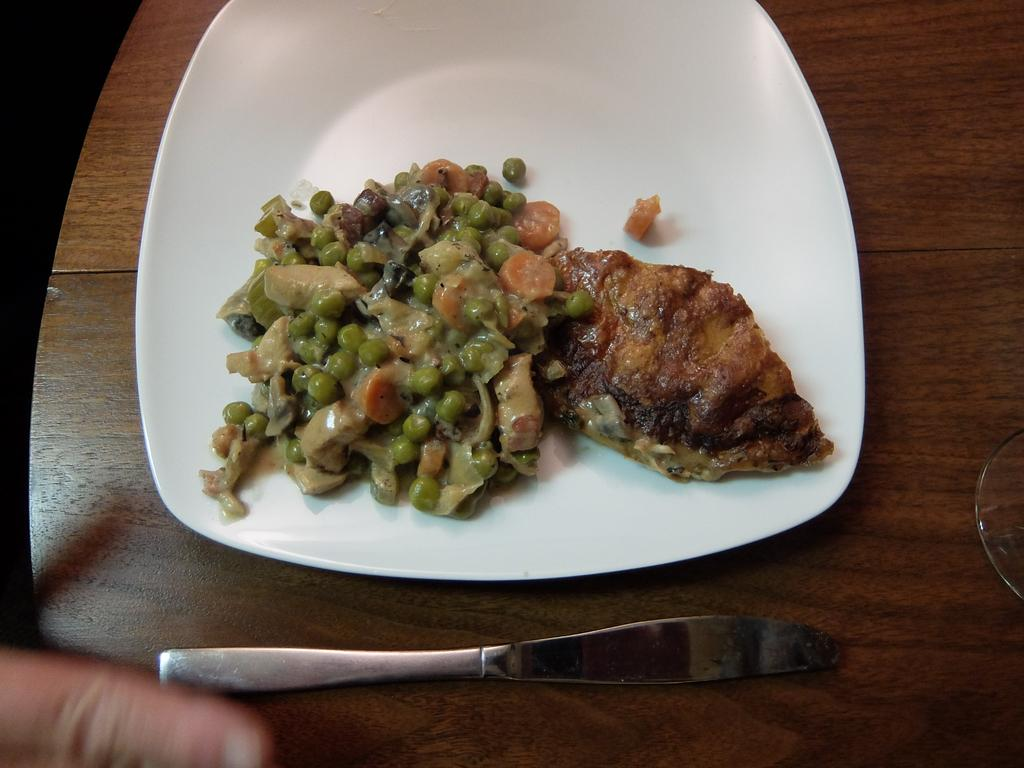What is on the plate that is visible in the image? There is food on a plate in the image. What utensil is on the table in the image? There is a spoon on the table in the image. What else can be seen on the table in the image? There is another object on the table in the image. Can you describe any part of a person in the image? A person's finger is visible at the bottom of the image. How many deer are visible in the image? There are no deer present in the image. What type of pies are on the tray in the image? There is no tray or pies present in the image. 